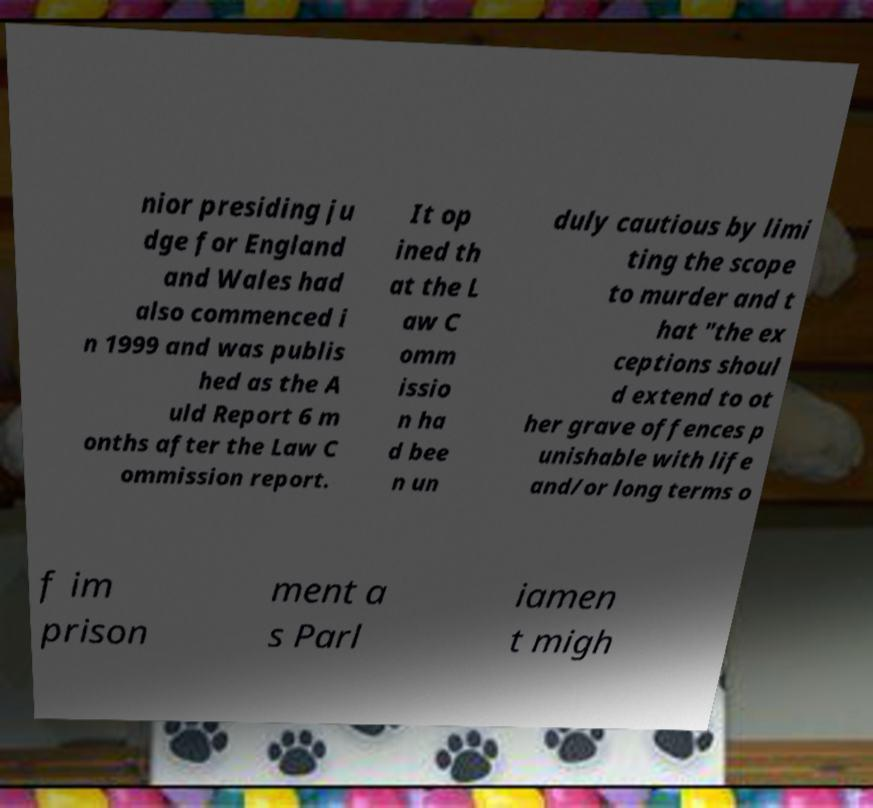Can you read and provide the text displayed in the image?This photo seems to have some interesting text. Can you extract and type it out for me? nior presiding ju dge for England and Wales had also commenced i n 1999 and was publis hed as the A uld Report 6 m onths after the Law C ommission report. It op ined th at the L aw C omm issio n ha d bee n un duly cautious by limi ting the scope to murder and t hat "the ex ceptions shoul d extend to ot her grave offences p unishable with life and/or long terms o f im prison ment a s Parl iamen t migh 